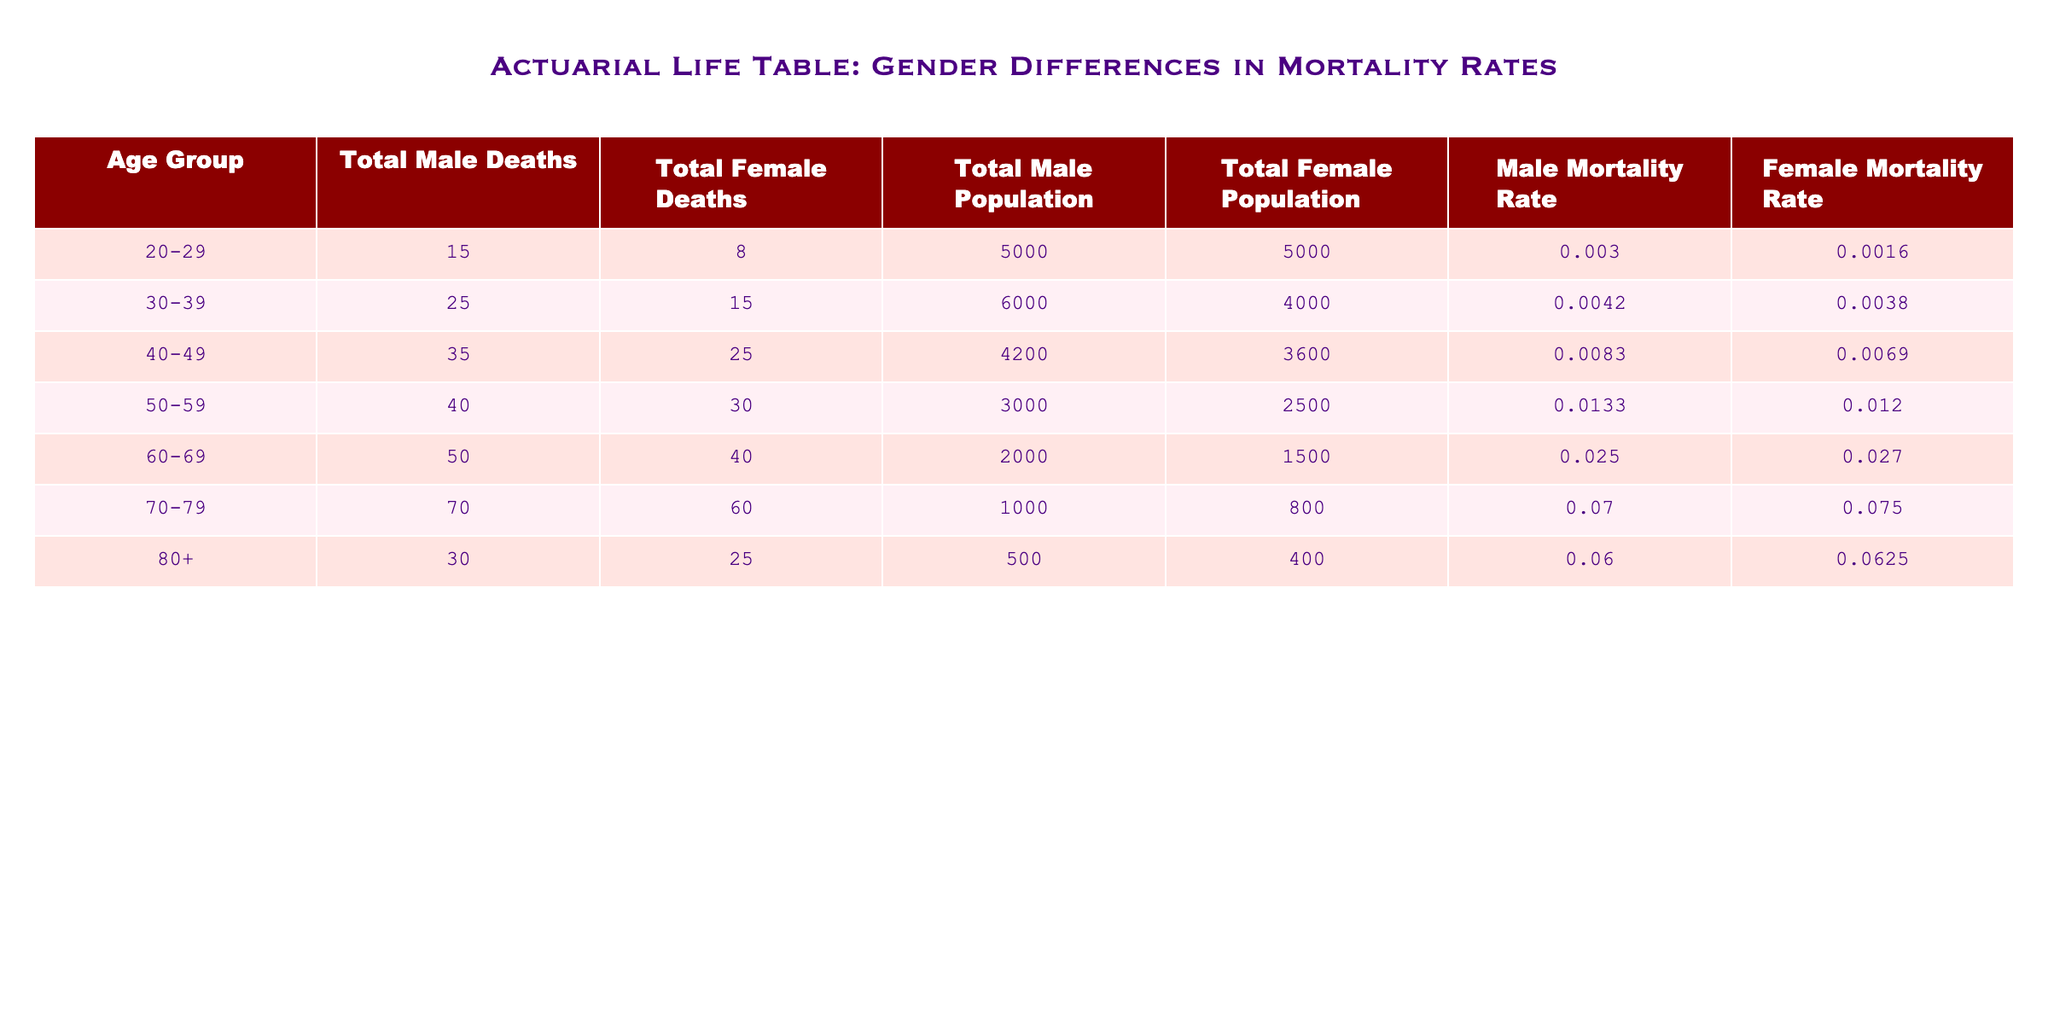What is the male mortality rate for the age group 40-49? From the table, the male mortality rate for the age group 40-49 is listed directly in the corresponding row. It is 0.0083.
Answer: 0.0083 What is the total number of male deaths in the age group 60-69? Looking at the table, the total number of male deaths is specified under the "Total Male Deaths" column for the age group 60-69. It is 50.
Answer: 50 Is the female mortality rate higher in the age group 70-79 than in the age group 60-69? The female mortality rate for the age group 70-79 is 0.075, while for the age group 60-69 it is 0.027. Therefore, it is true that the female mortality rate is higher in 70-79 than in 60-69.
Answer: Yes What is the difference in the total number of deaths between males and females in the age group 50-59? The total male deaths in the 50-59 age group are 40, and total female deaths are 30. The difference is calculated as 40 - 30 = 10.
Answer: 10 What is the average male mortality rate across all age groups in the table? To find the average male mortality rate, add the male mortality rates for all age groups: 0.003 + 0.0042 + 0.0083 + 0.0133 + 0.025 + 0.07 + 0.06 = 0.1938. Divide this sum by the number of age groups, which is 7, resulting in an average of 0.1938 / 7 = approximately 0.0274.
Answer: 0.0274 Are there more total deaths for females than males in the age group 80+? The total deaths for females in the age group 80+ is 25, while for males it is 30. Since 25 is less than 30, it is false that there are more total deaths for females.
Answer: No What is the sum of total populations for the age group 30-39 and 40-49? The total male population for 30-39 is 6000, and for 40-49 is 4200. The total female population for 30-39 is 4000, and for 40-49 is 3600. Thus, the sum for both age groups is (6000 + 4200) + (4000 + 3600) = 18800.
Answer: 18800 Which age group has the lowest female mortality rate? The table provides the female mortality rates for each age group. By comparing these rates, the lowest rate is found in the age group 20-29, which is 0.0016.
Answer: 20-29 What percentage of total deaths in the age group 70-79 are male? In the age group 70-79, total male deaths are 70, and total female deaths are 60, leading to total deaths of 70 + 60 = 130. The percentage of male deaths is calculated as (70 / 130) * 100, which is approximately 53.85%.
Answer: 53.85% 